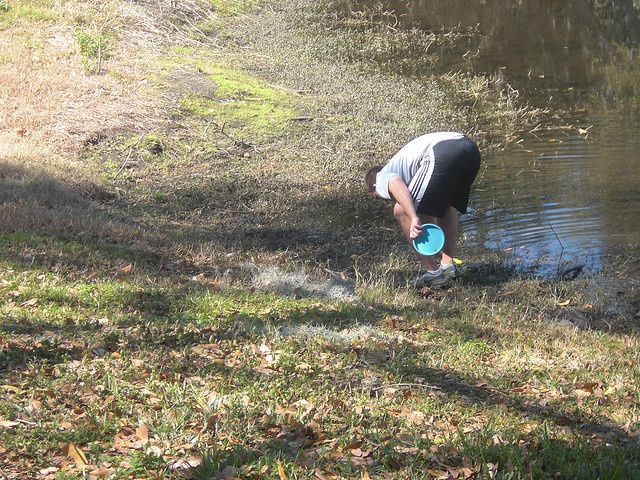Describe the objects in this image and their specific colors. I can see people in darkgray, black, white, and gray tones and frisbee in darkgray, lightblue, blue, cyan, and teal tones in this image. 